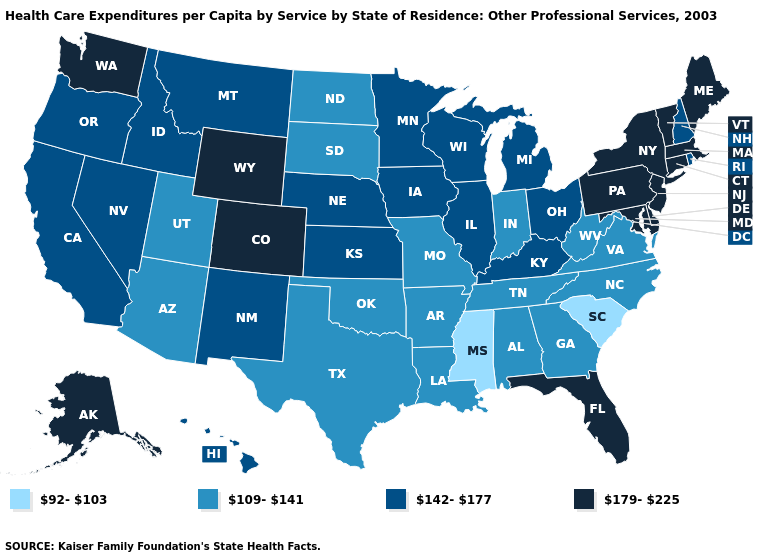Which states have the lowest value in the USA?
Write a very short answer. Mississippi, South Carolina. Name the states that have a value in the range 142-177?
Short answer required. California, Hawaii, Idaho, Illinois, Iowa, Kansas, Kentucky, Michigan, Minnesota, Montana, Nebraska, Nevada, New Hampshire, New Mexico, Ohio, Oregon, Rhode Island, Wisconsin. Does the map have missing data?
Keep it brief. No. Does Alaska have a lower value than Oregon?
Concise answer only. No. What is the value of Indiana?
Quick response, please. 109-141. Name the states that have a value in the range 142-177?
Quick response, please. California, Hawaii, Idaho, Illinois, Iowa, Kansas, Kentucky, Michigan, Minnesota, Montana, Nebraska, Nevada, New Hampshire, New Mexico, Ohio, Oregon, Rhode Island, Wisconsin. Does Kentucky have a higher value than Alabama?
Keep it brief. Yes. Name the states that have a value in the range 109-141?
Keep it brief. Alabama, Arizona, Arkansas, Georgia, Indiana, Louisiana, Missouri, North Carolina, North Dakota, Oklahoma, South Dakota, Tennessee, Texas, Utah, Virginia, West Virginia. What is the highest value in the USA?
Give a very brief answer. 179-225. Which states have the lowest value in the USA?
Answer briefly. Mississippi, South Carolina. What is the value of Illinois?
Quick response, please. 142-177. Which states have the highest value in the USA?
Be succinct. Alaska, Colorado, Connecticut, Delaware, Florida, Maine, Maryland, Massachusetts, New Jersey, New York, Pennsylvania, Vermont, Washington, Wyoming. Does Connecticut have a higher value than Maine?
Short answer required. No. What is the value of California?
Short answer required. 142-177. What is the value of Alabama?
Give a very brief answer. 109-141. 